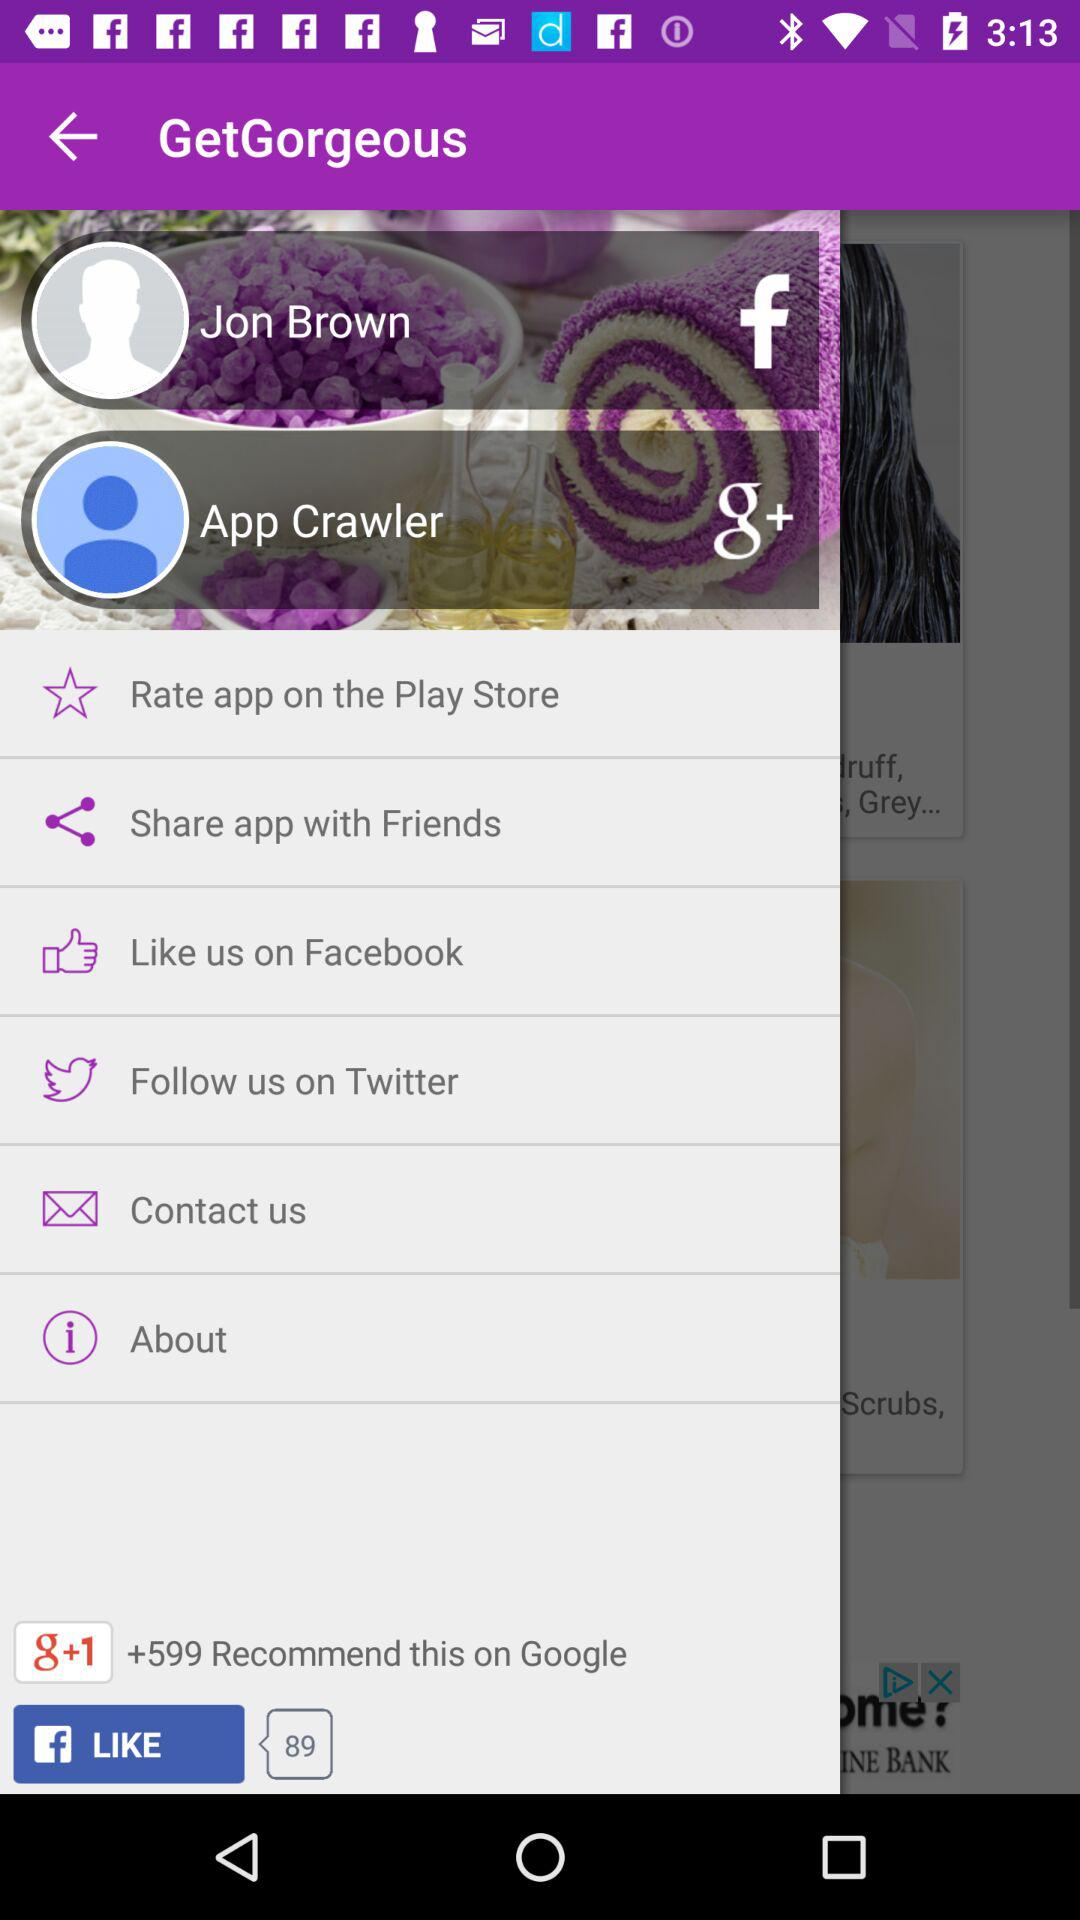What is the user name for "Google+"? The user name for "Google+" is App Crawler. 